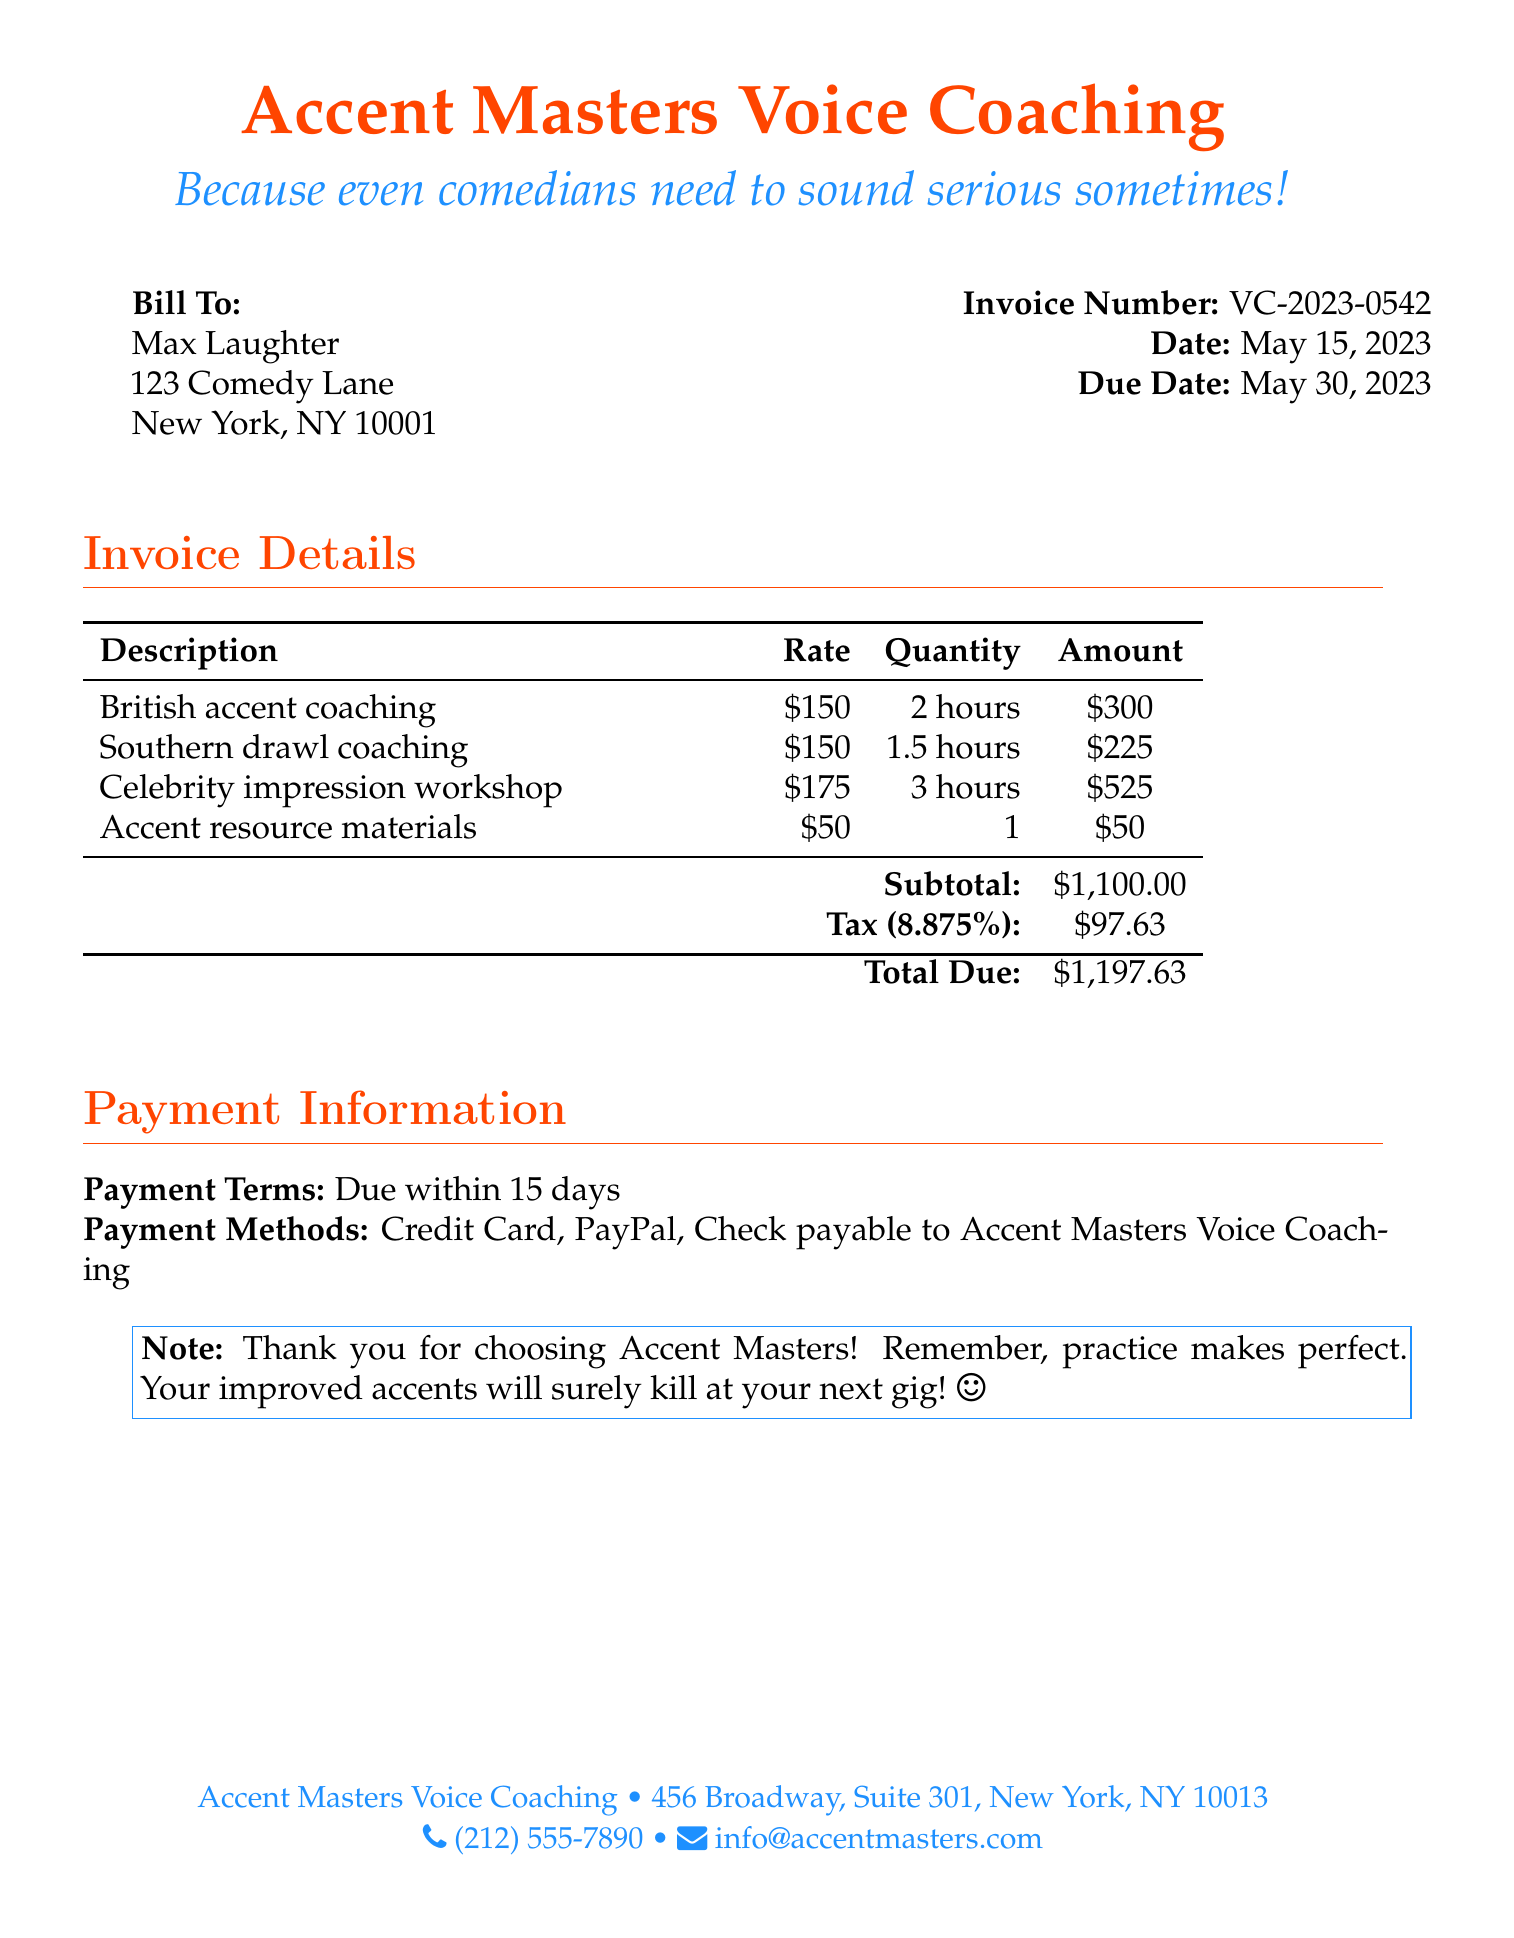What is the invoice number? The invoice number is a unique identifier for this billing document, which is VC-2023-0542.
Answer: VC-2023-0542 What is the due date for this invoice? The due date is specified as the last date by which payment should be made, which is May 30, 2023.
Answer: May 30, 2023 How many hours of celebrity impression workshop were billed? The hours of the workshop are included in the detailed breakdown, which indicates 3 hours.
Answer: 3 hours What is the subtotal amount? The subtotal amount is the sum of all the services provided before tax, which is $1,100.00.
Answer: $1,100.00 What is the payment term listed? The payment term gives an indication of when payment is expected, and it specifies due within 15 days.
Answer: Due within 15 days How much was charged for accent resource materials? The charge for accent resource materials is mentioned as a separate line item in the bill, which is $50.
Answer: $50 What is the tax rate applied? The tax rate is specified next to the tax amount in the document, which is 8.875%.
Answer: 8.875% What is the total amount due? The total amount due is the final amount that must be paid after including taxes, which is $1,197.63.
Answer: $1,197.63 What methods of payment are accepted? The document lists the acceptable payment methods, which are Credit Card, PayPal, and Check.
Answer: Credit Card, PayPal, Check 